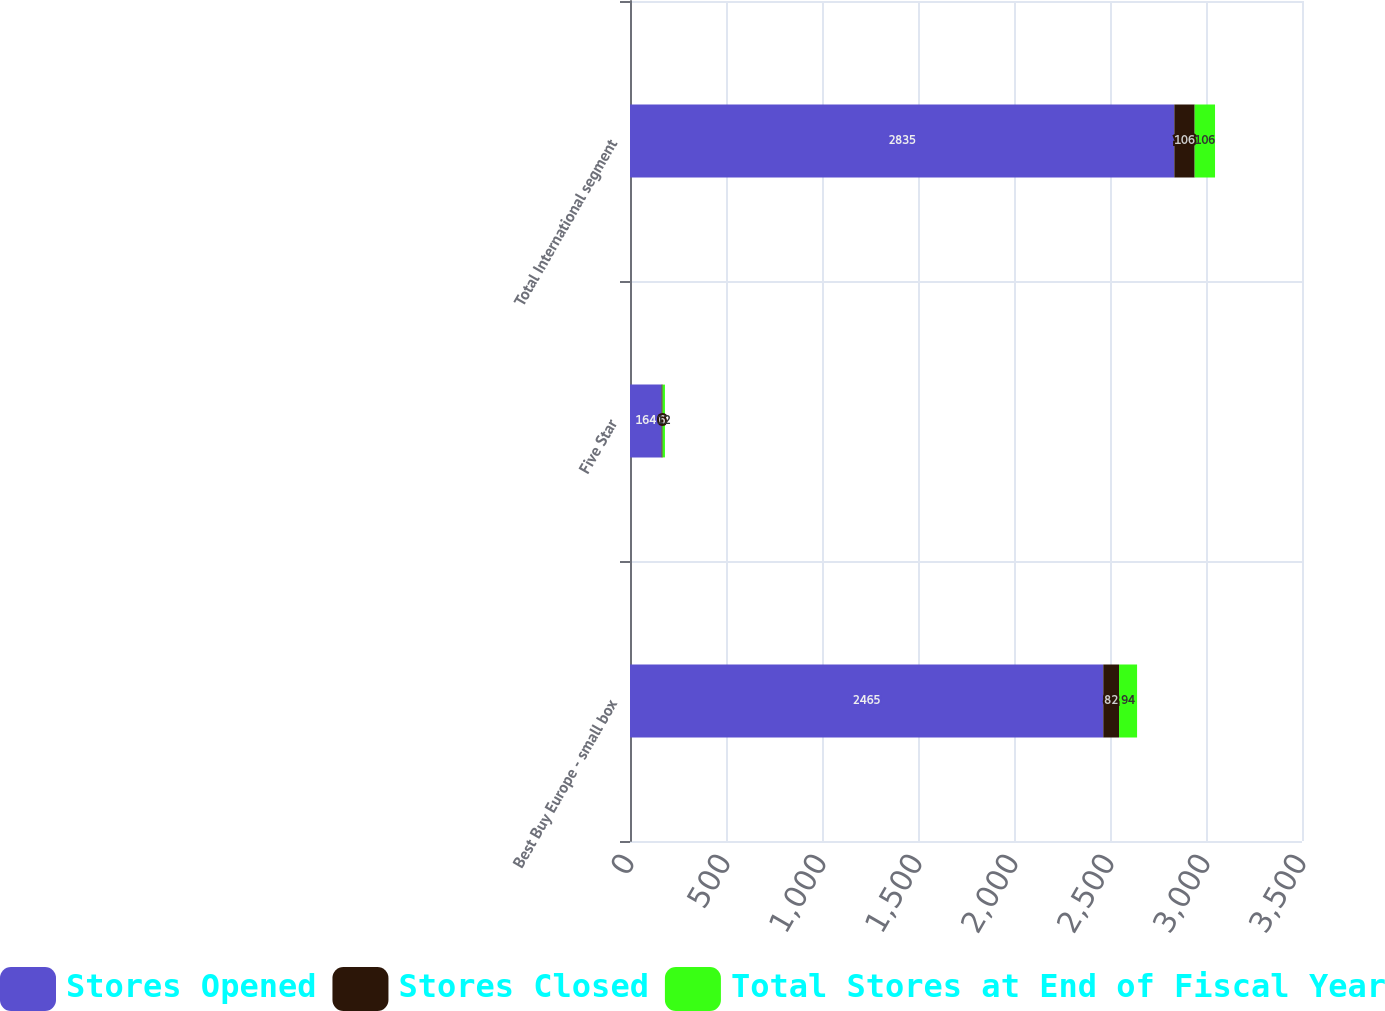Convert chart. <chart><loc_0><loc_0><loc_500><loc_500><stacked_bar_chart><ecel><fcel>Best Buy Europe - small box<fcel>Five Star<fcel>Total International segment<nl><fcel>Stores Opened<fcel>2465<fcel>164<fcel>2835<nl><fcel>Stores Closed<fcel>82<fcel>6<fcel>106<nl><fcel>Total Stores at End of Fiscal Year<fcel>94<fcel>12<fcel>106<nl></chart> 